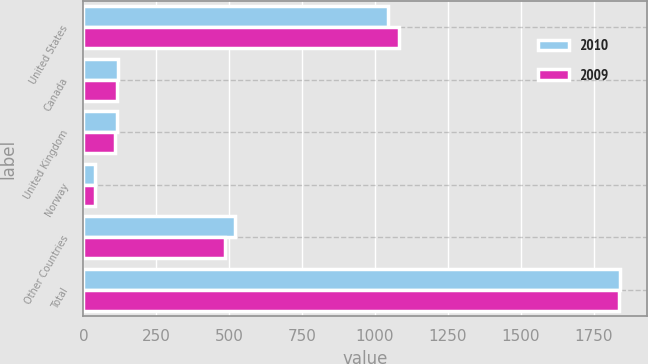Convert chart. <chart><loc_0><loc_0><loc_500><loc_500><stacked_bar_chart><ecel><fcel>United States<fcel>Canada<fcel>United Kingdom<fcel>Norway<fcel>Other Countries<fcel>Total<nl><fcel>2010<fcel>1045<fcel>118<fcel>116<fcel>40<fcel>521<fcel>1840<nl><fcel>2009<fcel>1082<fcel>116<fcel>110<fcel>41<fcel>487<fcel>1836<nl></chart> 